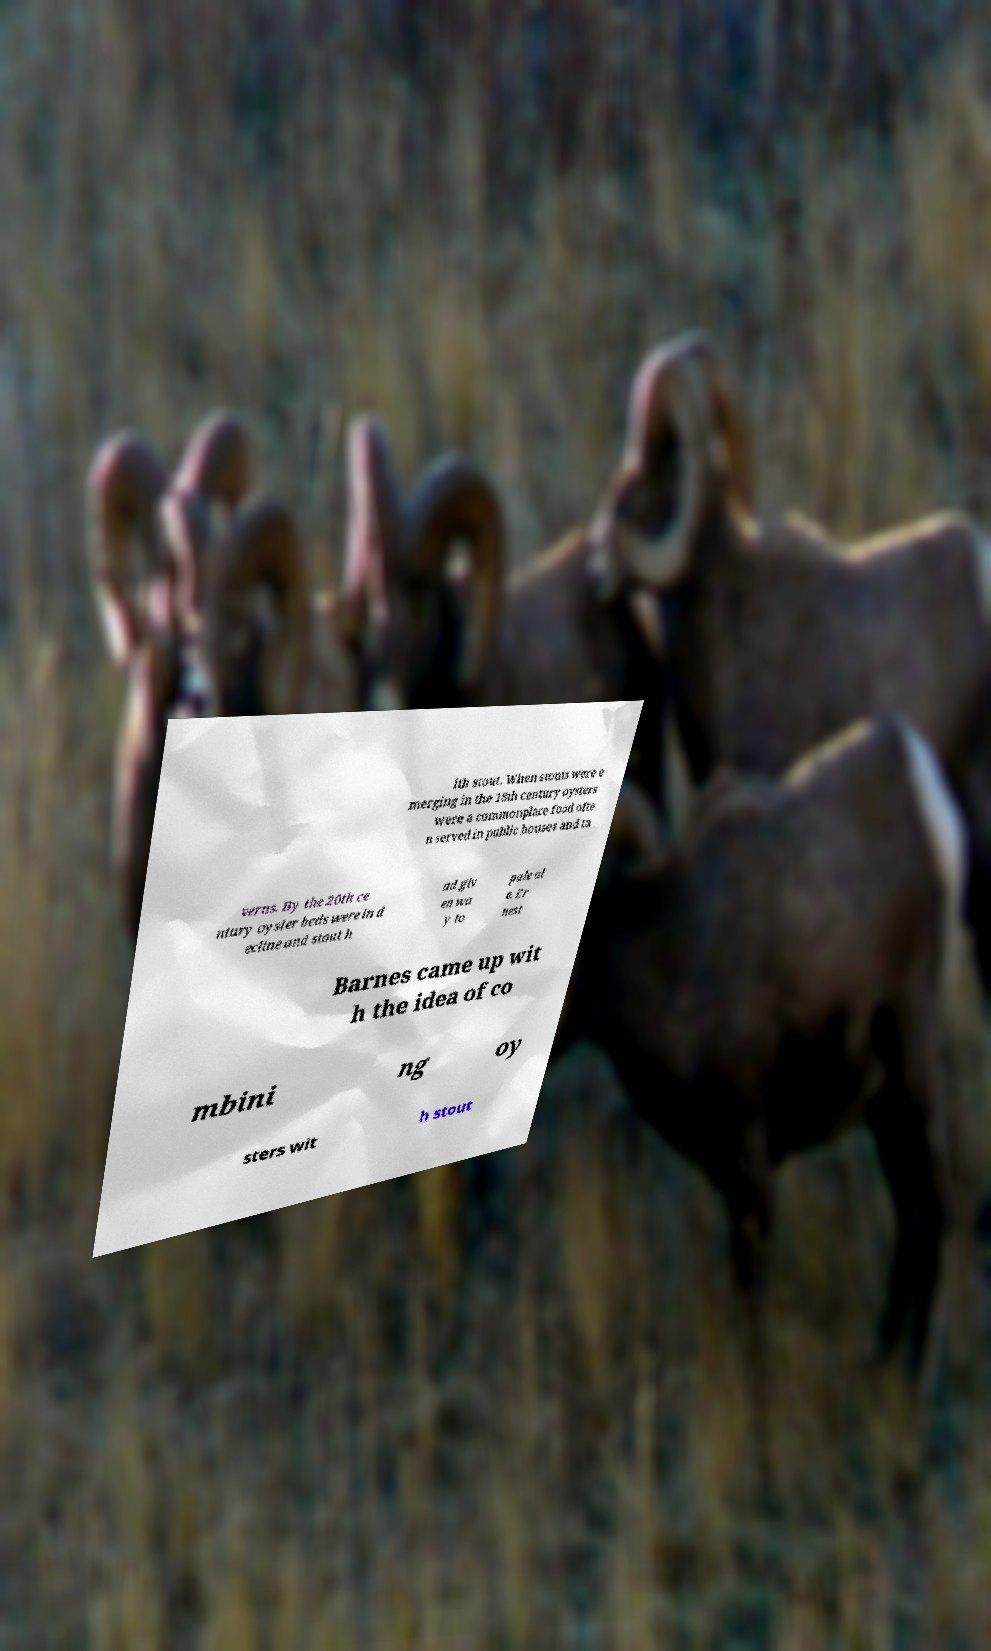I need the written content from this picture converted into text. Can you do that? ith stout. When stouts were e merging in the 18th century oysters were a commonplace food ofte n served in public houses and ta verns. By the 20th ce ntury oyster beds were in d ecline and stout h ad giv en wa y to pale al e. Er nest Barnes came up wit h the idea of co mbini ng oy sters wit h stout 